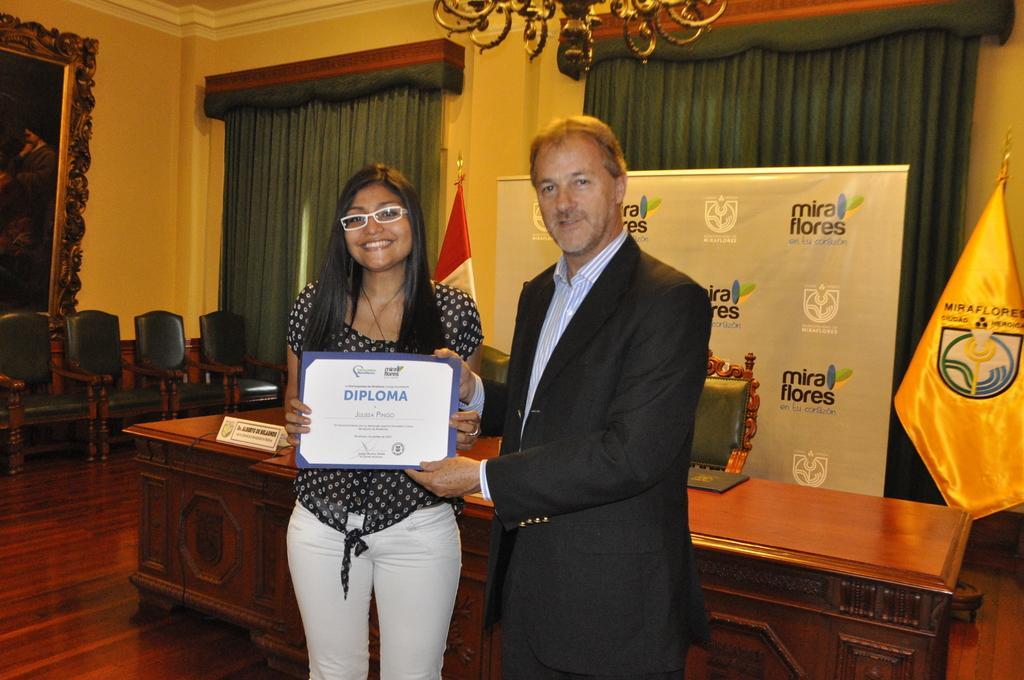How would you summarize this image in a sentence or two? This image consists of a man and a woman holding a certificate. In the background, there is a table along with the chair. To the right, there is a flag. In the background, there are curtains. To the left, there is a photo frame. At the bottom, there is a floor. 